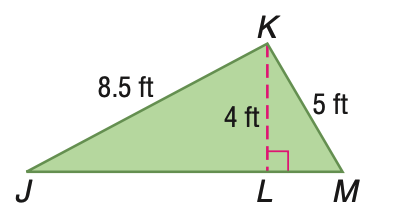Answer the mathemtical geometry problem and directly provide the correct option letter.
Question: Find the area of \triangle J K M.
Choices: A: 21 B: 21.25 C: 42 D: 42.5 A 